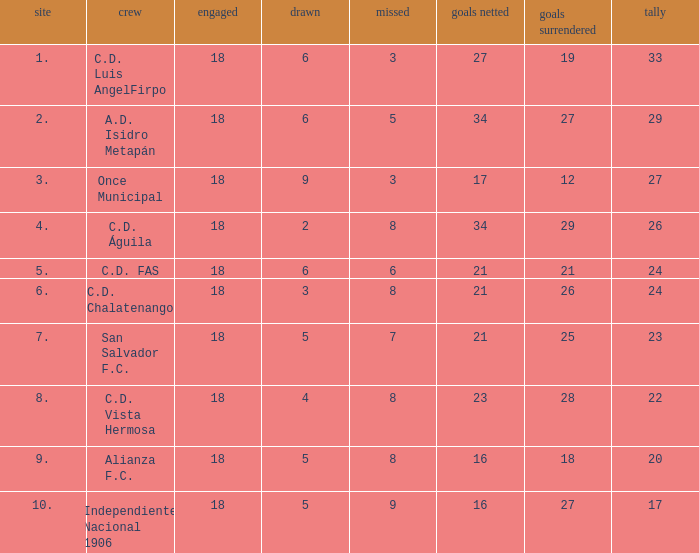Would you mind parsing the complete table? {'header': ['site', 'crew', 'engaged', 'drawn', 'missed', 'goals netted', 'goals surrendered', 'tally'], 'rows': [['1.', 'C.D. Luis AngelFirpo', '18', '6', '3', '27', '19', '33'], ['2.', 'A.D. Isidro Metapán', '18', '6', '5', '34', '27', '29'], ['3.', 'Once Municipal', '18', '9', '3', '17', '12', '27'], ['4.', 'C.D. Águila', '18', '2', '8', '34', '29', '26'], ['5.', 'C.D. FAS', '18', '6', '6', '21', '21', '24'], ['6.', 'C.D. Chalatenango', '18', '3', '8', '21', '26', '24'], ['7.', 'San Salvador F.C.', '18', '5', '7', '21', '25', '23'], ['8.', 'C.D. Vista Hermosa', '18', '4', '8', '23', '28', '22'], ['9.', 'Alianza F.C.', '18', '5', '8', '16', '18', '20'], ['10.', 'Independiente Nacional 1906', '18', '5', '9', '16', '27', '17']]} What's the place that Once Municipal has a lost greater than 3? None. 